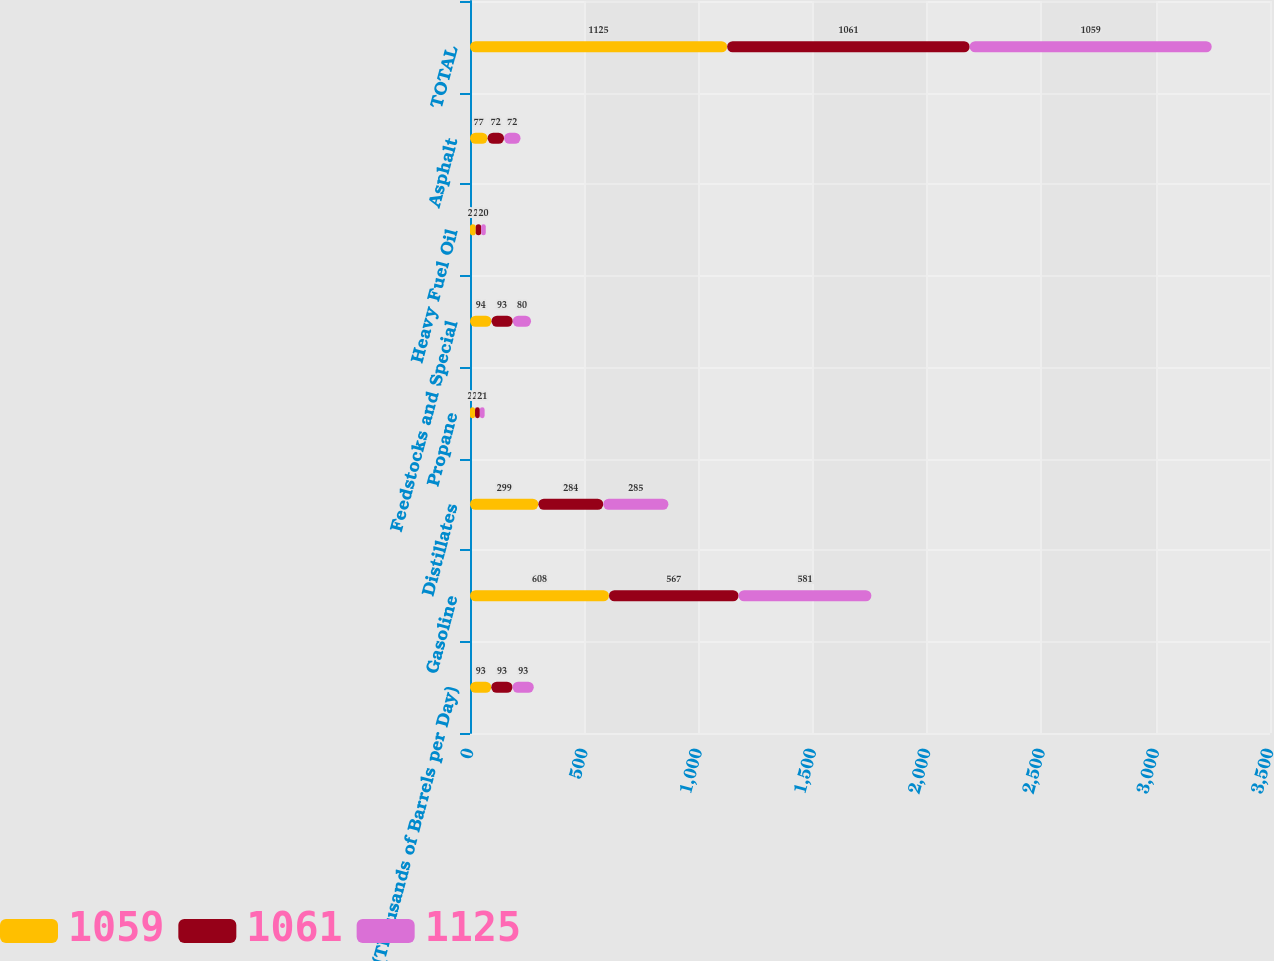Convert chart. <chart><loc_0><loc_0><loc_500><loc_500><stacked_bar_chart><ecel><fcel>(Thousands of Barrels per Day)<fcel>Gasoline<fcel>Distillates<fcel>Propane<fcel>Feedstocks and Special<fcel>Heavy Fuel Oil<fcel>Asphalt<fcel>TOTAL<nl><fcel>1059<fcel>93<fcel>608<fcel>299<fcel>22<fcel>94<fcel>25<fcel>77<fcel>1125<nl><fcel>1061<fcel>93<fcel>567<fcel>284<fcel>21<fcel>93<fcel>24<fcel>72<fcel>1061<nl><fcel>1125<fcel>93<fcel>581<fcel>285<fcel>21<fcel>80<fcel>20<fcel>72<fcel>1059<nl></chart> 